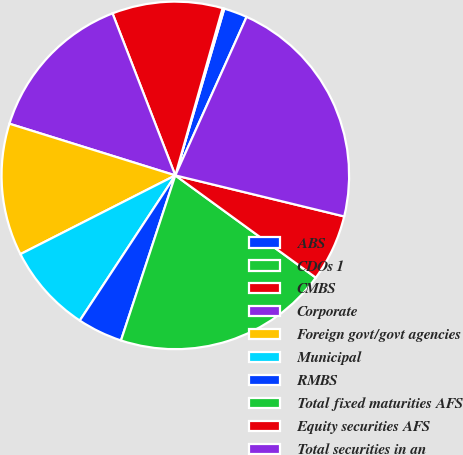Convert chart to OTSL. <chart><loc_0><loc_0><loc_500><loc_500><pie_chart><fcel>ABS<fcel>CDOs 1<fcel>CMBS<fcel>Corporate<fcel>Foreign govt/govt agencies<fcel>Municipal<fcel>RMBS<fcel>Total fixed maturities AFS<fcel>Equity securities AFS<fcel>Total securities in an<nl><fcel>2.18%<fcel>0.16%<fcel>10.27%<fcel>14.31%<fcel>12.29%<fcel>8.25%<fcel>4.2%<fcel>20.05%<fcel>6.22%<fcel>22.07%<nl></chart> 